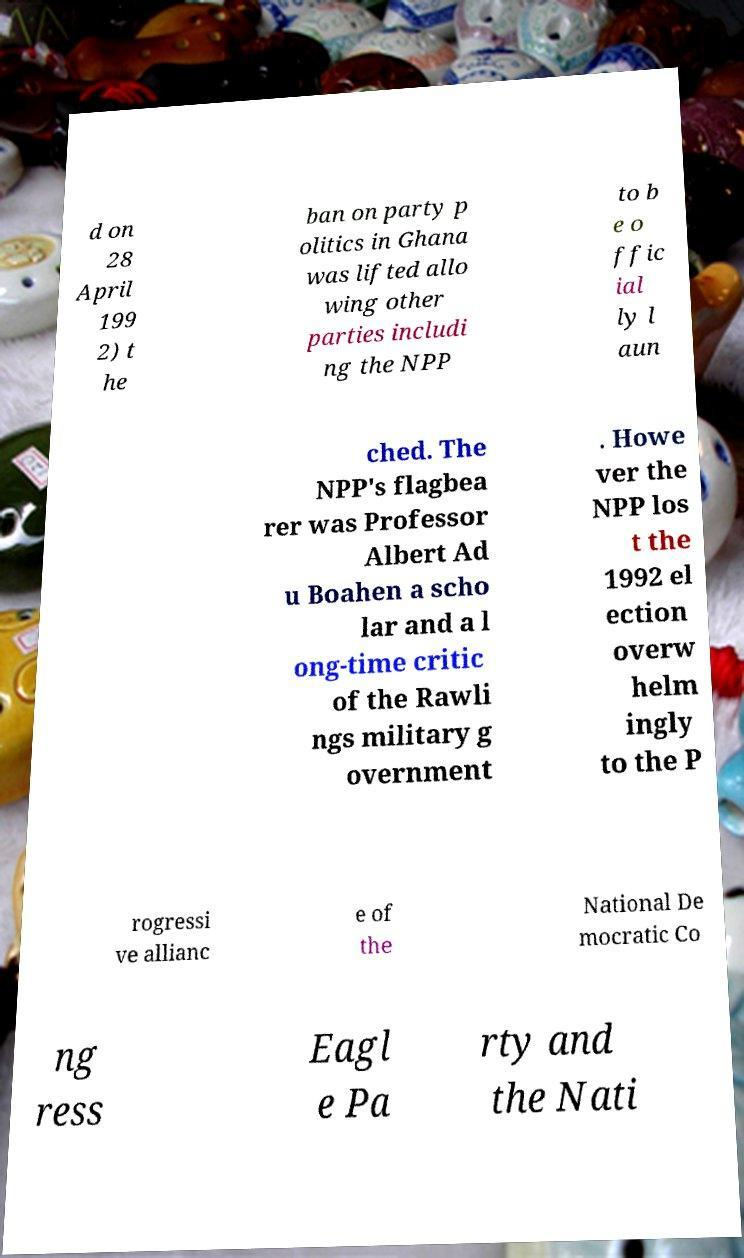For documentation purposes, I need the text within this image transcribed. Could you provide that? d on 28 April 199 2) t he ban on party p olitics in Ghana was lifted allo wing other parties includi ng the NPP to b e o ffic ial ly l aun ched. The NPP's flagbea rer was Professor Albert Ad u Boahen a scho lar and a l ong-time critic of the Rawli ngs military g overnment . Howe ver the NPP los t the 1992 el ection overw helm ingly to the P rogressi ve allianc e of the National De mocratic Co ng ress Eagl e Pa rty and the Nati 